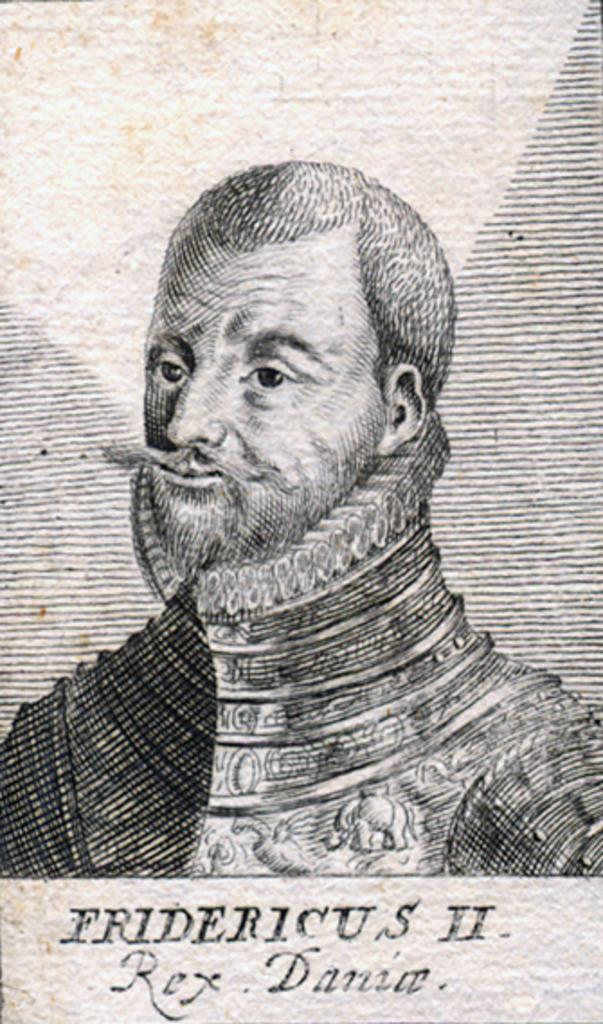What is depicted in the image? The image contains a drawing of a person. What is the person in the drawing wearing? The person in the drawing is wearing a dress. What facial feature does the person in the drawing have? The person in the drawing has a long mustache. What type of teeth can be seen in the drawing? There are no teeth visible in the drawing, as it features a person with a long mustache. What type of calendar is hanging on the wall in the drawing? There is no calendar present in the drawing; it only features a person with a long mustache. 